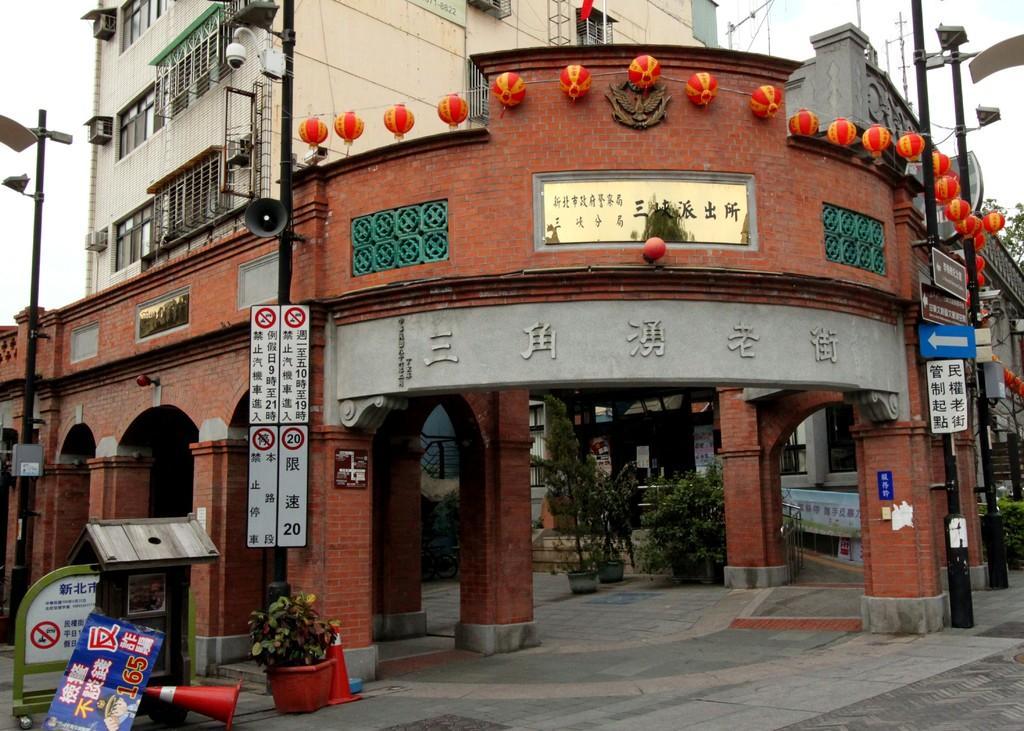Can you describe this image briefly? In this image we can see buildings, decorative items, electric poles, boards with some text, plants, safety cones. At the bottom of the image there is road. 